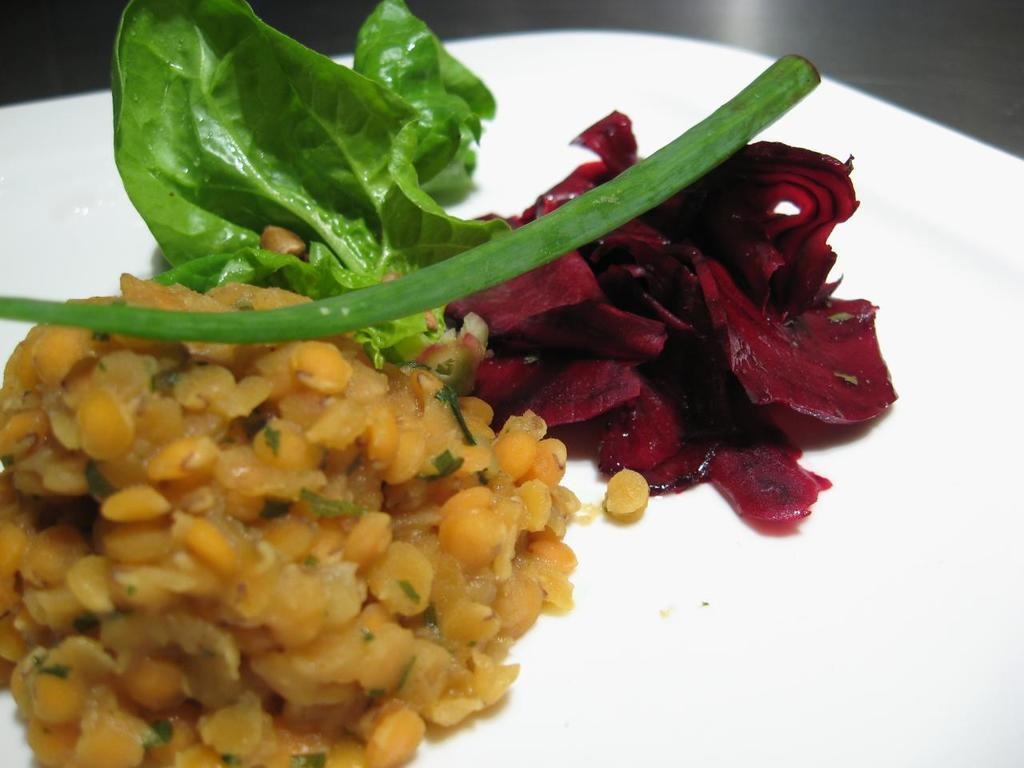What is present on the plate in the image? There is food on the plate, including green leafy vegetables and beetroot. Can you describe the type of food on the plate? The food on the plate includes green leafy vegetables and beetroot. What type of sign can be seen on the plate in the image? There is no sign present on the plate in the image. 